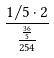Convert formula to latex. <formula><loc_0><loc_0><loc_500><loc_500>\frac { 1 / 5 \cdot 2 } { \frac { \frac { 3 6 } { 5 } } { 2 5 4 } }</formula> 